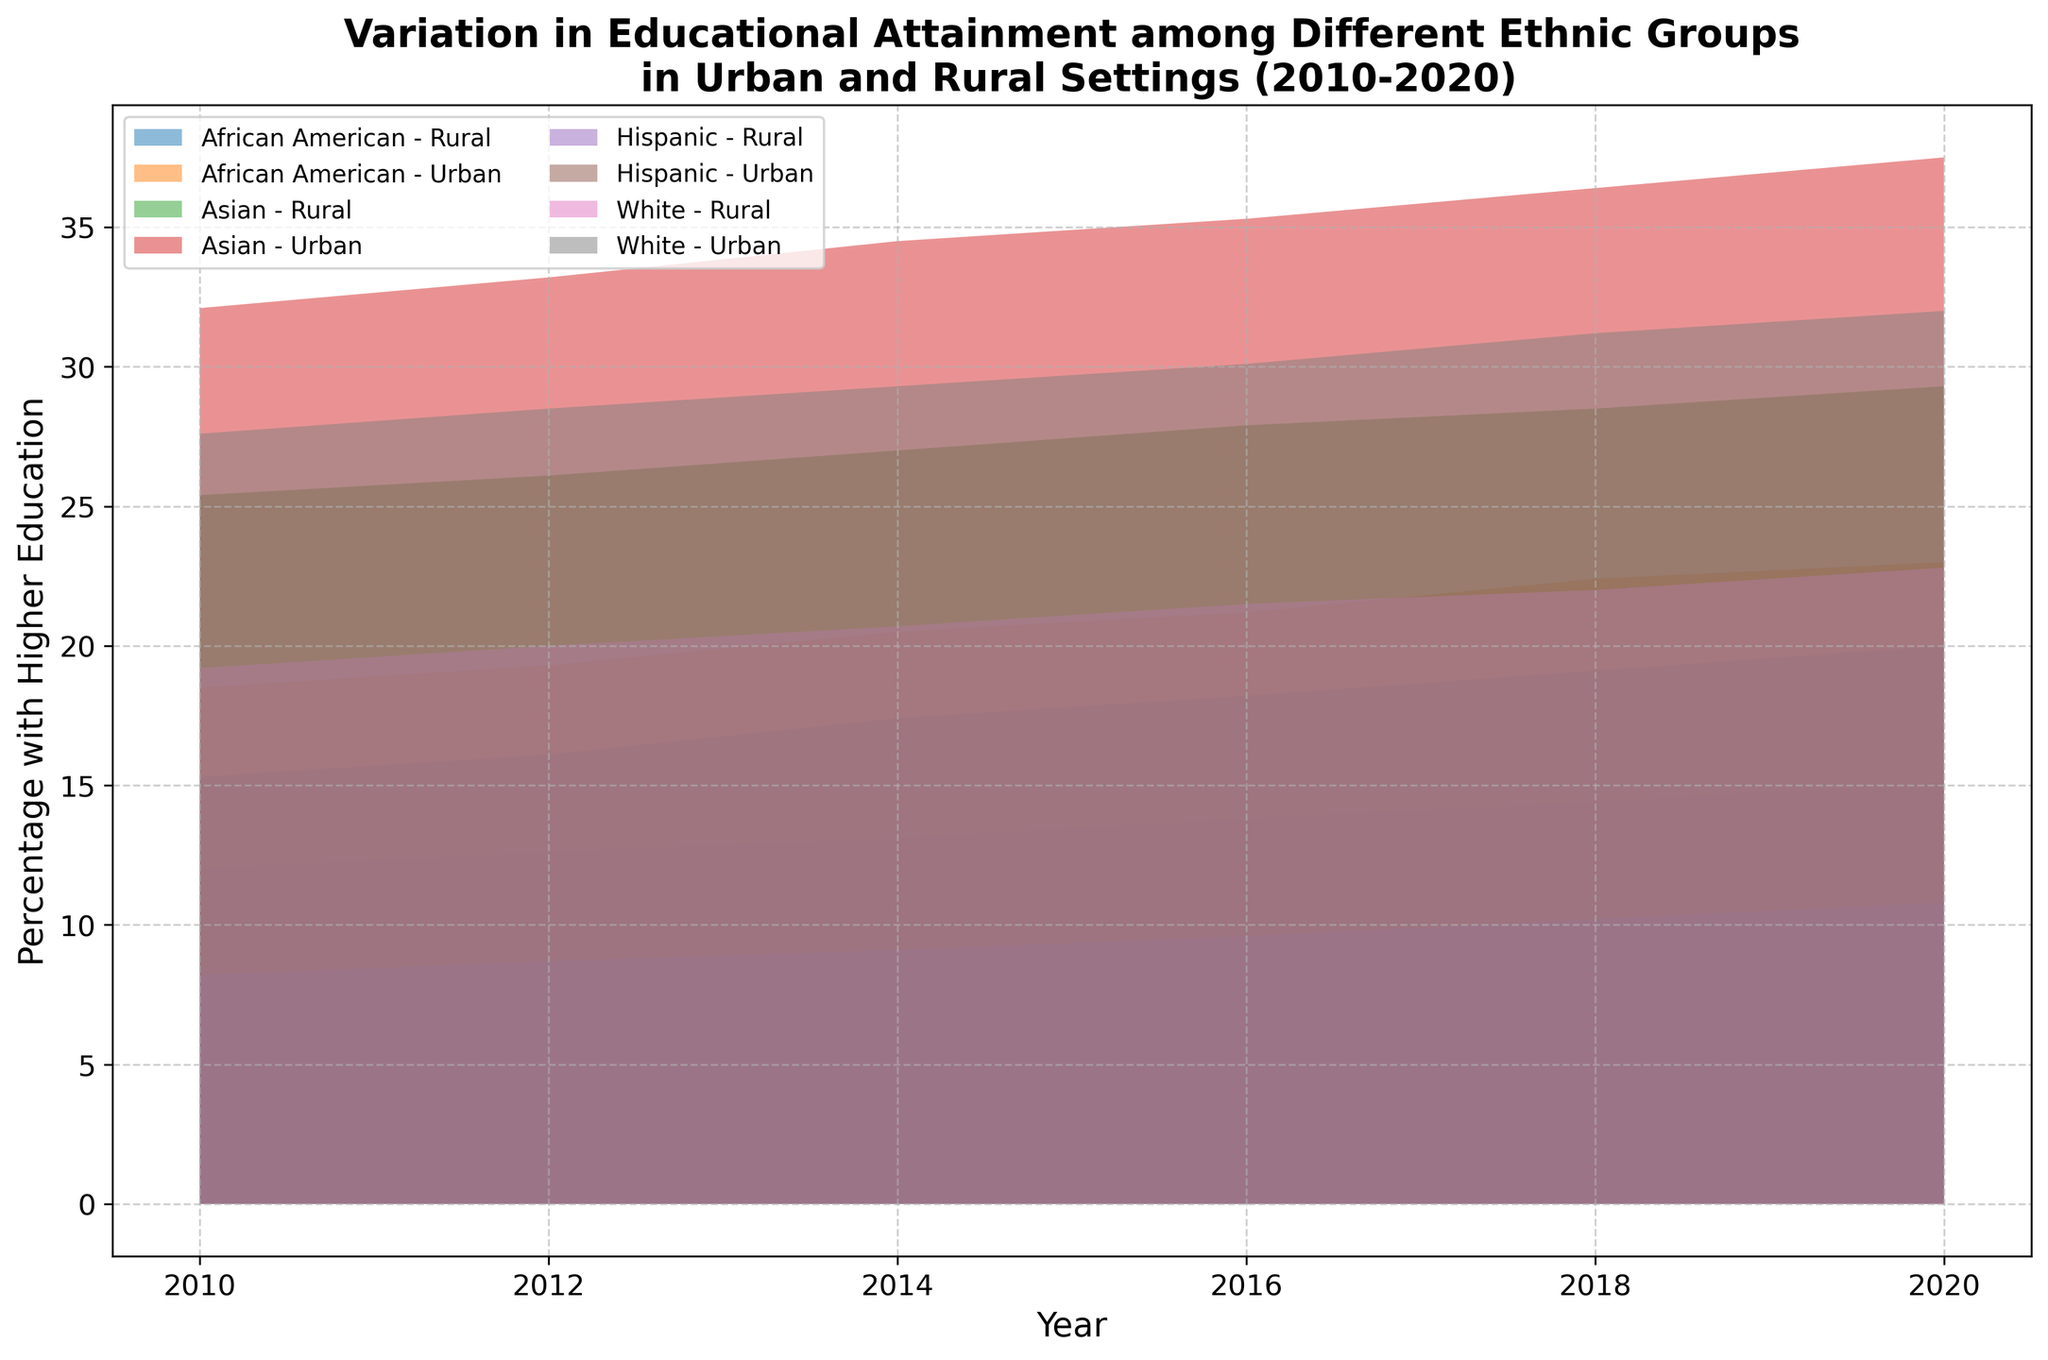Which ethnic group had the highest percentage of higher education attainment in urban settings in 2020? To find the ethnic group with the highest percentage in urban settings for the year 2020, locate the highest point among urban groups. The Asian ethnic group had the highest value at 37.5%.
Answer: Asian What was the general trend in higher education attainment for Hispanics in rural settings from 2010 to 2020? Observe the pattern of the area representing Hispanics in rural settings over the years 2010 to 2020. The trend shows a gradual increase from 8.2% in 2010 to 10.8% in 2020.
Answer: Gradual increase How did the percentage change for African Americans in rural settings from 2014 to 2020? Identify the percentages for African Americans in rural settings for 2014 (13.1%) and 2020 (15.1%), then calculate the difference. The change is 15.1% - 13.1% = 2.0%.
Answer: 2.0% Which ethnic group showed the smallest difference in higher education attainment between urban and rural settings in 2020? Compare the differences between urban and rural settings for each ethnic group in 2020. Asians had the urban percentage at 37.5% and rural at 29.3%, a difference of 8.2%, which is the smallest compared to other groups.
Answer: Asian On average, how did the higher education attainment for Whites in urban settings change per year from 2010 to 2020? Calculate the average yearly change by dividing the total percentage change by the number of years. The change from 2010 (27.6%) to 2020 (32.0%) is 32.0% - 27.6% = 4.4%. Over 10 years, the average change is 4.4%/10 = 0.44% per year.
Answer: 0.44% Which ethnic group in rural settings had the highest increase in higher education attainment from 2010 to 2020? Calculate the differences for each ethnic group in rural settings between 2010 and 2020. Africans Americans had the highest increase from 12.0% to 15.1%, an increase of 3.1%.
Answer: African American Among the urban settings, which ethnic group had a consistent increase in higher education attainment every recorded year? Evaluate the yearly data for each group in urban settings to find which had a continuous increase. The Hispanic group showed consistent increases from 2010 to 2020.
Answer: Hispanic 